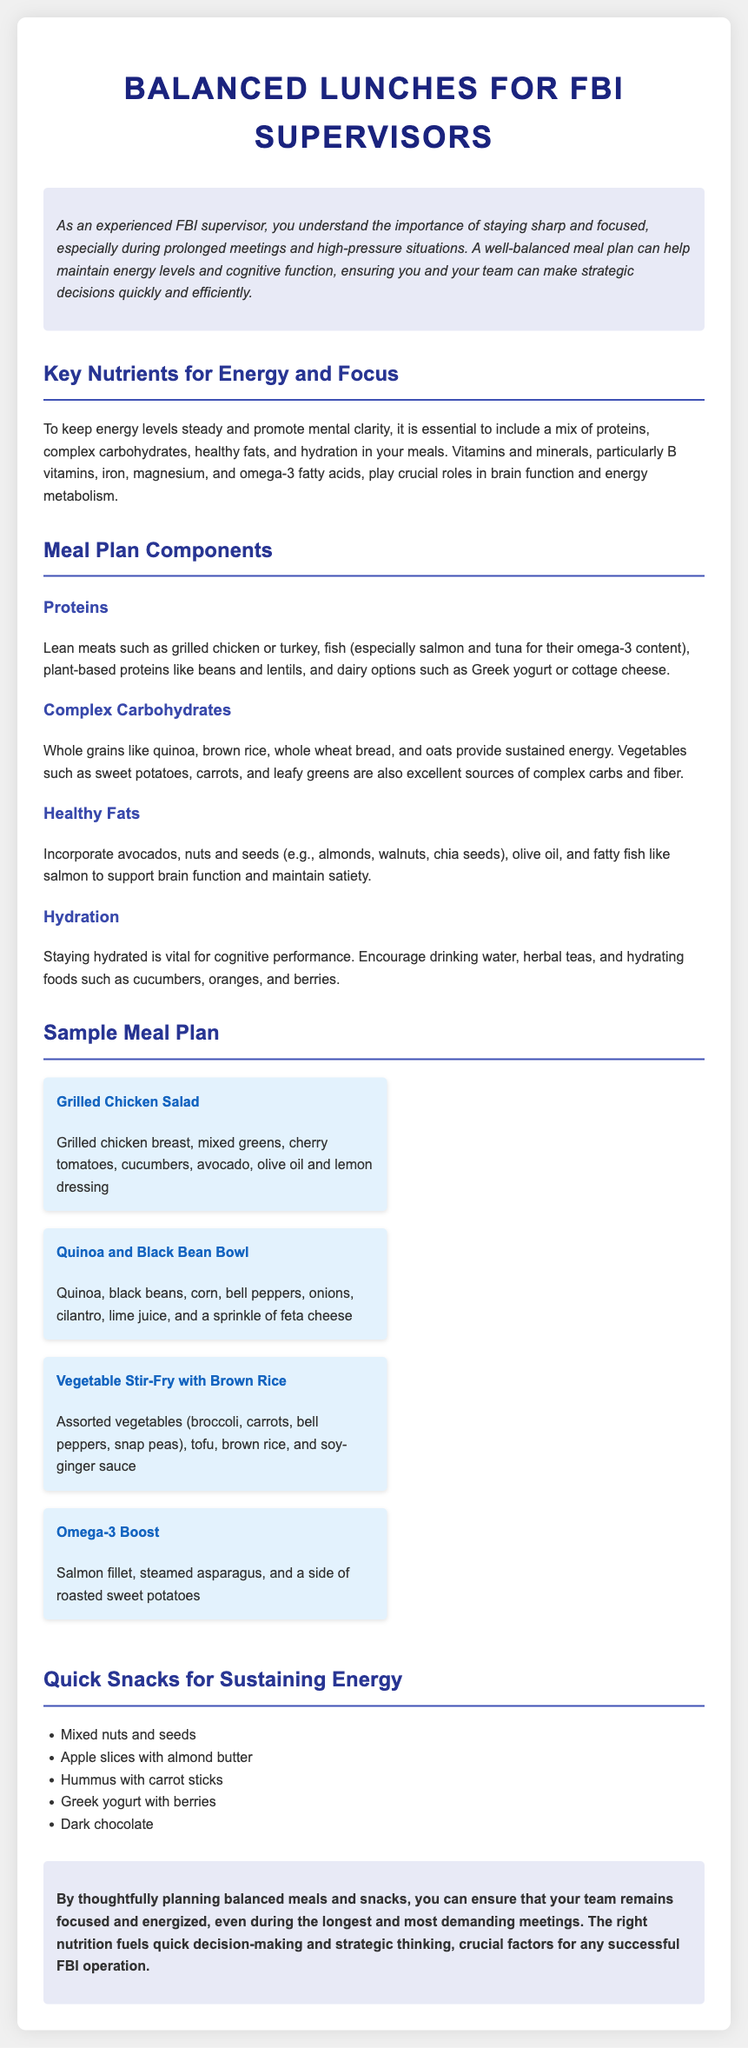what are the key nutrients mentioned for energy and focus? The document lists the key nutrients essential for maintaining energy levels and promoting mental clarity.
Answer: proteins, complex carbohydrates, healthy fats, hydration which meal includes salmon? The document provides a specific meal that features salmon as a main ingredient.
Answer: Omega-3 Boost how many sample meals are provided in the meal plan? The document states the number of sample meals included in the meal plan section.
Answer: four what type of yogurt is suggested in the proteins section? The proteins section specifies a type of yogurt beneficial for inclusion in balanced meals.
Answer: Greek yogurt which vegetable is prominently featured in the Vegetable Stir-Fry recipe? The description of the Vegetable Stir-Fry lists specific vegetables, one of which is notably featured.
Answer: broccoli what is included in the quick snacks list? The document provides a list of items categorized as quick snacks for sustaining energy.
Answer: Mixed nuts and seeds what is the main carbohydrate source in the Quinoa and Black Bean Bowl? The document highlights the primary carbohydrate source present in the Quinoa and Black Bean Bowl.
Answer: Quinoa how does the document suggest maintaining hydration? The hydration section outlines specific methods for ensuring adequate hydration throughout the day.
Answer: drinking water, herbal teas 